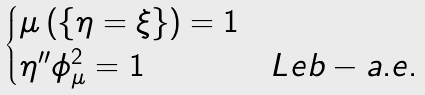Convert formula to latex. <formula><loc_0><loc_0><loc_500><loc_500>\begin{cases} \mu \left ( \{ \eta = \xi \} \right ) = 1 \\ \eta ^ { \prime \prime } \phi _ { \mu } ^ { 2 } = 1 & L e b - a . e . \end{cases}</formula> 